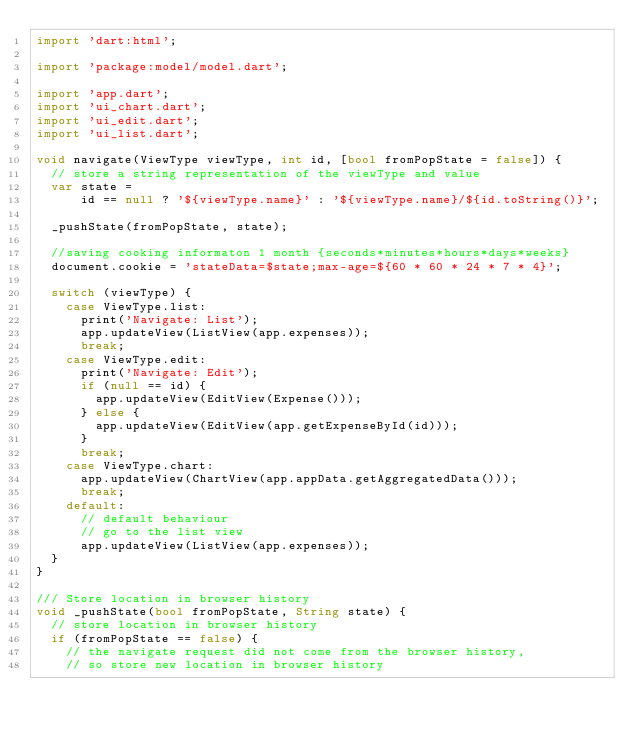<code> <loc_0><loc_0><loc_500><loc_500><_Dart_>import 'dart:html';

import 'package:model/model.dart';

import 'app.dart';
import 'ui_chart.dart';
import 'ui_edit.dart';
import 'ui_list.dart';

void navigate(ViewType viewType, int id, [bool fromPopState = false]) {
  // store a string representation of the viewType and value
  var state =
      id == null ? '${viewType.name}' : '${viewType.name}/${id.toString()}';

  _pushState(fromPopState, state);

  //saving cooking informaton 1 month {seconds*minutes*hours*days*weeks}
  document.cookie = 'stateData=$state;max-age=${60 * 60 * 24 * 7 * 4}';
 
  switch (viewType) {
    case ViewType.list:
      print('Navigate: List');
      app.updateView(ListView(app.expenses));
      break;
    case ViewType.edit:
      print('Navigate: Edit');
      if (null == id) {
        app.updateView(EditView(Expense()));
      } else {
        app.updateView(EditView(app.getExpenseById(id)));
      }
      break;
    case ViewType.chart:
      app.updateView(ChartView(app.appData.getAggregatedData()));
      break;
    default:
      // default behaviour
      // go to the list view
      app.updateView(ListView(app.expenses));
  }
}

/// Store location in browser history
void _pushState(bool fromPopState, String state) {
  // store location in browser history
  if (fromPopState == false) {
    // the navigate request did not come from the browser history,
    // so store new location in browser history</code> 